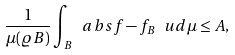Convert formula to latex. <formula><loc_0><loc_0><loc_500><loc_500>\frac { 1 } { \mu ( \varrho B ) } \int _ { B } \ a b s { f - f _ { B } } \ u d \mu \leq A ,</formula> 